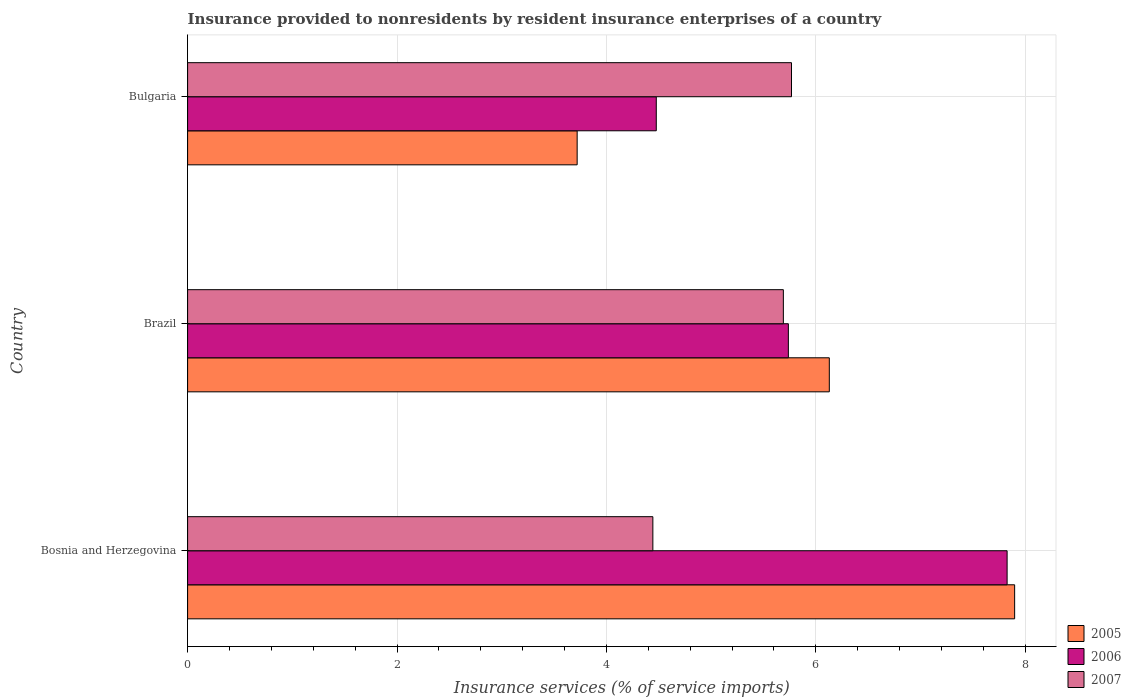How many different coloured bars are there?
Offer a terse response. 3. Are the number of bars per tick equal to the number of legend labels?
Give a very brief answer. Yes. Are the number of bars on each tick of the Y-axis equal?
Ensure brevity in your answer.  Yes. How many bars are there on the 2nd tick from the top?
Provide a short and direct response. 3. What is the label of the 3rd group of bars from the top?
Give a very brief answer. Bosnia and Herzegovina. In how many cases, is the number of bars for a given country not equal to the number of legend labels?
Give a very brief answer. 0. What is the insurance provided to nonresidents in 2006 in Brazil?
Your answer should be very brief. 5.74. Across all countries, what is the maximum insurance provided to nonresidents in 2006?
Provide a short and direct response. 7.83. Across all countries, what is the minimum insurance provided to nonresidents in 2007?
Give a very brief answer. 4.44. In which country was the insurance provided to nonresidents in 2005 minimum?
Your response must be concise. Bulgaria. What is the total insurance provided to nonresidents in 2005 in the graph?
Your answer should be compact. 17.75. What is the difference between the insurance provided to nonresidents in 2005 in Brazil and that in Bulgaria?
Your answer should be very brief. 2.41. What is the difference between the insurance provided to nonresidents in 2005 in Bosnia and Herzegovina and the insurance provided to nonresidents in 2007 in Bulgaria?
Keep it short and to the point. 2.13. What is the average insurance provided to nonresidents in 2006 per country?
Provide a short and direct response. 6.01. What is the difference between the insurance provided to nonresidents in 2007 and insurance provided to nonresidents in 2005 in Bulgaria?
Provide a short and direct response. 2.05. In how many countries, is the insurance provided to nonresidents in 2006 greater than 7.2 %?
Your answer should be compact. 1. What is the ratio of the insurance provided to nonresidents in 2007 in Brazil to that in Bulgaria?
Give a very brief answer. 0.99. Is the insurance provided to nonresidents in 2006 in Bosnia and Herzegovina less than that in Brazil?
Give a very brief answer. No. Is the difference between the insurance provided to nonresidents in 2007 in Bosnia and Herzegovina and Brazil greater than the difference between the insurance provided to nonresidents in 2005 in Bosnia and Herzegovina and Brazil?
Your answer should be very brief. No. What is the difference between the highest and the second highest insurance provided to nonresidents in 2006?
Offer a terse response. 2.09. What is the difference between the highest and the lowest insurance provided to nonresidents in 2005?
Provide a short and direct response. 4.18. Is the sum of the insurance provided to nonresidents in 2006 in Brazil and Bulgaria greater than the maximum insurance provided to nonresidents in 2005 across all countries?
Your response must be concise. Yes. What does the 3rd bar from the bottom in Brazil represents?
Your answer should be very brief. 2007. Is it the case that in every country, the sum of the insurance provided to nonresidents in 2005 and insurance provided to nonresidents in 2007 is greater than the insurance provided to nonresidents in 2006?
Provide a short and direct response. Yes. Are all the bars in the graph horizontal?
Your answer should be compact. Yes. What is the difference between two consecutive major ticks on the X-axis?
Your answer should be compact. 2. Are the values on the major ticks of X-axis written in scientific E-notation?
Your answer should be very brief. No. Does the graph contain any zero values?
Your response must be concise. No. Does the graph contain grids?
Keep it short and to the point. Yes. How many legend labels are there?
Make the answer very short. 3. What is the title of the graph?
Offer a terse response. Insurance provided to nonresidents by resident insurance enterprises of a country. Does "1968" appear as one of the legend labels in the graph?
Keep it short and to the point. No. What is the label or title of the X-axis?
Offer a very short reply. Insurance services (% of service imports). What is the Insurance services (% of service imports) in 2005 in Bosnia and Herzegovina?
Your answer should be compact. 7.9. What is the Insurance services (% of service imports) in 2006 in Bosnia and Herzegovina?
Make the answer very short. 7.83. What is the Insurance services (% of service imports) in 2007 in Bosnia and Herzegovina?
Your response must be concise. 4.44. What is the Insurance services (% of service imports) of 2005 in Brazil?
Your response must be concise. 6.13. What is the Insurance services (% of service imports) in 2006 in Brazil?
Provide a succinct answer. 5.74. What is the Insurance services (% of service imports) of 2007 in Brazil?
Ensure brevity in your answer.  5.69. What is the Insurance services (% of service imports) of 2005 in Bulgaria?
Provide a short and direct response. 3.72. What is the Insurance services (% of service imports) in 2006 in Bulgaria?
Your answer should be very brief. 4.48. What is the Insurance services (% of service imports) of 2007 in Bulgaria?
Offer a very short reply. 5.77. Across all countries, what is the maximum Insurance services (% of service imports) in 2005?
Keep it short and to the point. 7.9. Across all countries, what is the maximum Insurance services (% of service imports) in 2006?
Your answer should be compact. 7.83. Across all countries, what is the maximum Insurance services (% of service imports) of 2007?
Provide a succinct answer. 5.77. Across all countries, what is the minimum Insurance services (% of service imports) of 2005?
Your response must be concise. 3.72. Across all countries, what is the minimum Insurance services (% of service imports) in 2006?
Your response must be concise. 4.48. Across all countries, what is the minimum Insurance services (% of service imports) of 2007?
Offer a very short reply. 4.44. What is the total Insurance services (% of service imports) of 2005 in the graph?
Your answer should be compact. 17.75. What is the total Insurance services (% of service imports) in 2006 in the graph?
Your answer should be very brief. 18.04. What is the total Insurance services (% of service imports) in 2007 in the graph?
Provide a short and direct response. 15.9. What is the difference between the Insurance services (% of service imports) of 2005 in Bosnia and Herzegovina and that in Brazil?
Offer a very short reply. 1.77. What is the difference between the Insurance services (% of service imports) in 2006 in Bosnia and Herzegovina and that in Brazil?
Ensure brevity in your answer.  2.09. What is the difference between the Insurance services (% of service imports) of 2007 in Bosnia and Herzegovina and that in Brazil?
Your answer should be very brief. -1.25. What is the difference between the Insurance services (% of service imports) of 2005 in Bosnia and Herzegovina and that in Bulgaria?
Offer a very short reply. 4.18. What is the difference between the Insurance services (% of service imports) in 2006 in Bosnia and Herzegovina and that in Bulgaria?
Provide a succinct answer. 3.35. What is the difference between the Insurance services (% of service imports) of 2007 in Bosnia and Herzegovina and that in Bulgaria?
Offer a terse response. -1.32. What is the difference between the Insurance services (% of service imports) of 2005 in Brazil and that in Bulgaria?
Your answer should be very brief. 2.41. What is the difference between the Insurance services (% of service imports) in 2006 in Brazil and that in Bulgaria?
Offer a very short reply. 1.26. What is the difference between the Insurance services (% of service imports) of 2007 in Brazil and that in Bulgaria?
Provide a succinct answer. -0.08. What is the difference between the Insurance services (% of service imports) in 2005 in Bosnia and Herzegovina and the Insurance services (% of service imports) in 2006 in Brazil?
Your response must be concise. 2.16. What is the difference between the Insurance services (% of service imports) in 2005 in Bosnia and Herzegovina and the Insurance services (% of service imports) in 2007 in Brazil?
Make the answer very short. 2.21. What is the difference between the Insurance services (% of service imports) in 2006 in Bosnia and Herzegovina and the Insurance services (% of service imports) in 2007 in Brazil?
Make the answer very short. 2.14. What is the difference between the Insurance services (% of service imports) in 2005 in Bosnia and Herzegovina and the Insurance services (% of service imports) in 2006 in Bulgaria?
Ensure brevity in your answer.  3.42. What is the difference between the Insurance services (% of service imports) in 2005 in Bosnia and Herzegovina and the Insurance services (% of service imports) in 2007 in Bulgaria?
Offer a terse response. 2.13. What is the difference between the Insurance services (% of service imports) of 2006 in Bosnia and Herzegovina and the Insurance services (% of service imports) of 2007 in Bulgaria?
Provide a short and direct response. 2.06. What is the difference between the Insurance services (% of service imports) of 2005 in Brazil and the Insurance services (% of service imports) of 2006 in Bulgaria?
Make the answer very short. 1.65. What is the difference between the Insurance services (% of service imports) of 2005 in Brazil and the Insurance services (% of service imports) of 2007 in Bulgaria?
Keep it short and to the point. 0.36. What is the difference between the Insurance services (% of service imports) in 2006 in Brazil and the Insurance services (% of service imports) in 2007 in Bulgaria?
Your answer should be compact. -0.03. What is the average Insurance services (% of service imports) of 2005 per country?
Provide a succinct answer. 5.92. What is the average Insurance services (% of service imports) in 2006 per country?
Keep it short and to the point. 6.01. What is the average Insurance services (% of service imports) of 2007 per country?
Your answer should be compact. 5.3. What is the difference between the Insurance services (% of service imports) in 2005 and Insurance services (% of service imports) in 2006 in Bosnia and Herzegovina?
Offer a terse response. 0.07. What is the difference between the Insurance services (% of service imports) in 2005 and Insurance services (% of service imports) in 2007 in Bosnia and Herzegovina?
Provide a succinct answer. 3.46. What is the difference between the Insurance services (% of service imports) of 2006 and Insurance services (% of service imports) of 2007 in Bosnia and Herzegovina?
Ensure brevity in your answer.  3.38. What is the difference between the Insurance services (% of service imports) of 2005 and Insurance services (% of service imports) of 2006 in Brazil?
Make the answer very short. 0.39. What is the difference between the Insurance services (% of service imports) in 2005 and Insurance services (% of service imports) in 2007 in Brazil?
Give a very brief answer. 0.44. What is the difference between the Insurance services (% of service imports) of 2006 and Insurance services (% of service imports) of 2007 in Brazil?
Your response must be concise. 0.05. What is the difference between the Insurance services (% of service imports) of 2005 and Insurance services (% of service imports) of 2006 in Bulgaria?
Your response must be concise. -0.76. What is the difference between the Insurance services (% of service imports) in 2005 and Insurance services (% of service imports) in 2007 in Bulgaria?
Ensure brevity in your answer.  -2.05. What is the difference between the Insurance services (% of service imports) of 2006 and Insurance services (% of service imports) of 2007 in Bulgaria?
Provide a succinct answer. -1.29. What is the ratio of the Insurance services (% of service imports) of 2005 in Bosnia and Herzegovina to that in Brazil?
Offer a very short reply. 1.29. What is the ratio of the Insurance services (% of service imports) of 2006 in Bosnia and Herzegovina to that in Brazil?
Your answer should be very brief. 1.36. What is the ratio of the Insurance services (% of service imports) in 2007 in Bosnia and Herzegovina to that in Brazil?
Ensure brevity in your answer.  0.78. What is the ratio of the Insurance services (% of service imports) in 2005 in Bosnia and Herzegovina to that in Bulgaria?
Offer a very short reply. 2.12. What is the ratio of the Insurance services (% of service imports) of 2006 in Bosnia and Herzegovina to that in Bulgaria?
Your response must be concise. 1.75. What is the ratio of the Insurance services (% of service imports) of 2007 in Bosnia and Herzegovina to that in Bulgaria?
Offer a terse response. 0.77. What is the ratio of the Insurance services (% of service imports) in 2005 in Brazil to that in Bulgaria?
Ensure brevity in your answer.  1.65. What is the ratio of the Insurance services (% of service imports) in 2006 in Brazil to that in Bulgaria?
Make the answer very short. 1.28. What is the ratio of the Insurance services (% of service imports) in 2007 in Brazil to that in Bulgaria?
Keep it short and to the point. 0.99. What is the difference between the highest and the second highest Insurance services (% of service imports) of 2005?
Provide a succinct answer. 1.77. What is the difference between the highest and the second highest Insurance services (% of service imports) of 2006?
Your response must be concise. 2.09. What is the difference between the highest and the second highest Insurance services (% of service imports) of 2007?
Your answer should be compact. 0.08. What is the difference between the highest and the lowest Insurance services (% of service imports) in 2005?
Provide a succinct answer. 4.18. What is the difference between the highest and the lowest Insurance services (% of service imports) of 2006?
Provide a succinct answer. 3.35. What is the difference between the highest and the lowest Insurance services (% of service imports) in 2007?
Provide a short and direct response. 1.32. 